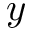<formula> <loc_0><loc_0><loc_500><loc_500>y</formula> 